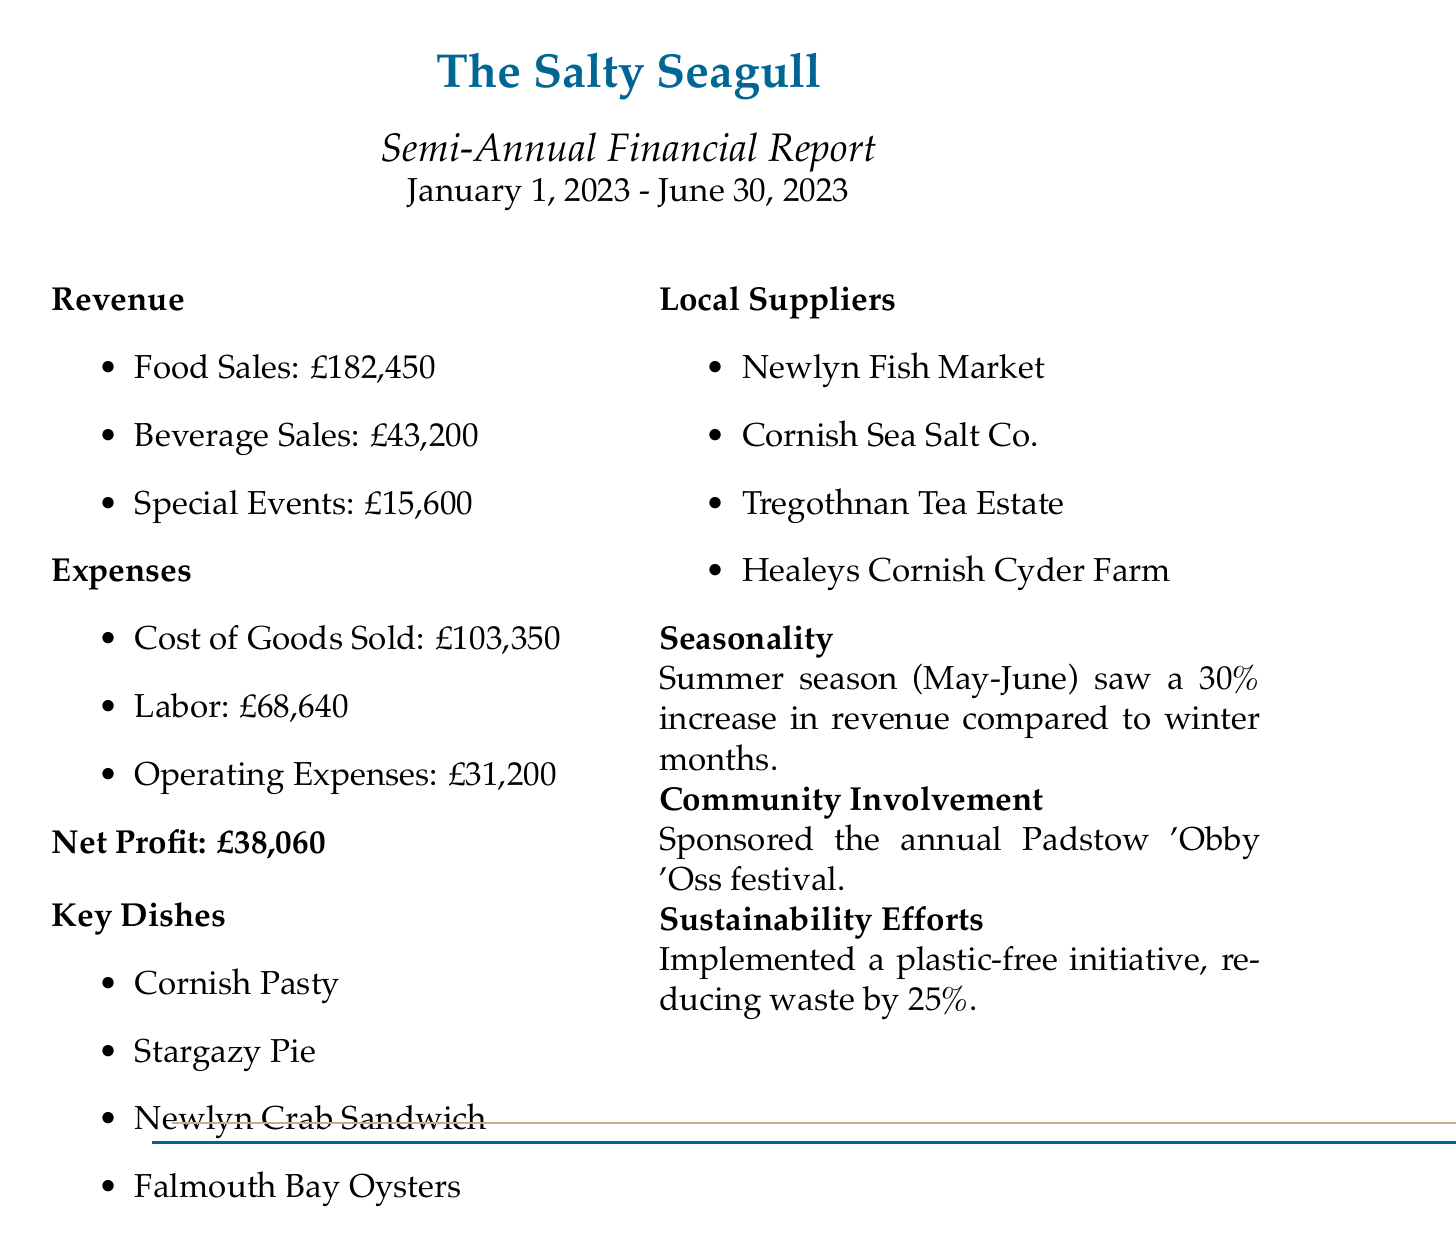What is the total revenue? The total revenue is the sum of food sales, beverage sales, and special events in the document, which is 182450 + 43200 + 15600 = 243250.
Answer: 243250 What is the net profit? The net profit is explicitly stated in the document as the difference between total revenue and total expenses.
Answer: 38060 What were the beverage sales? The document explicitly shows the beverage sales amount.
Answer: 43200 What is the cost of goods sold? The cost of goods sold is the total of seafood, other ingredients, and beverages in the expenses section, which is 68300 + 22150 + 12900 = 103350.
Answer: 103350 Which festival did the restaurant sponsor? The document mentions the annual festival sponsored by the restaurant.
Answer: Padstow 'Obby 'Oss festival How much did the restaurant spend on labor? The expenses related to labor are specified in the document as a sum of wages and payroll taxes.
Answer: 68640 What was the percentage increase in revenue during the summer season? This information is stated in the seasonality notes of the document.
Answer: 30% Which suppliers does the restaurant work with? The document lists the suppliers in the local suppliers section.
Answer: Newlyn Fish Market, Cornish Sea Salt Co., Tregothnan Tea Estate, Healeys Cornish Cyder Farm What sustainability effort did the restaurant implement? The document highlights a specific sustainability effort made by the restaurant.
Answer: Plastic-free initiative, reducing waste by 25% What key dish is featured in the restaurant? The document lists key dishes served, making it clear which dishes are highlighted.
Answer: Cornish Pasty 